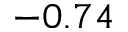Convert formula to latex. <formula><loc_0><loc_0><loc_500><loc_500>- 0 . 7 4</formula> 